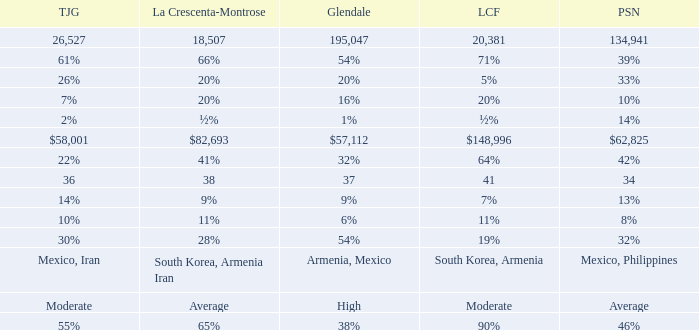If la canada flintridge is 5%, what is the proportion of glendale? 20%. 